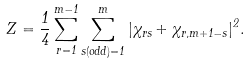Convert formula to latex. <formula><loc_0><loc_0><loc_500><loc_500>Z = \frac { 1 } { 4 } \sum _ { r = 1 } ^ { m - 1 } \sum _ { s ( o d d ) = 1 } ^ { m } | \chi _ { r s } + \chi _ { r , m + 1 - s } | ^ { 2 } .</formula> 